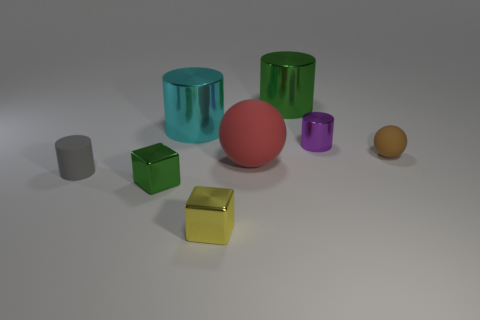Subtract all purple cylinders. How many cylinders are left? 3 Add 1 tiny yellow shiny blocks. How many objects exist? 9 Subtract all purple cylinders. How many cylinders are left? 3 Subtract 1 spheres. How many spheres are left? 1 Add 3 cyan metallic objects. How many cyan metallic objects are left? 4 Add 2 small cylinders. How many small cylinders exist? 4 Subtract 0 purple cubes. How many objects are left? 8 Subtract all balls. How many objects are left? 6 Subtract all brown balls. Subtract all cyan cylinders. How many balls are left? 1 Subtract all yellow blocks. How many green cylinders are left? 1 